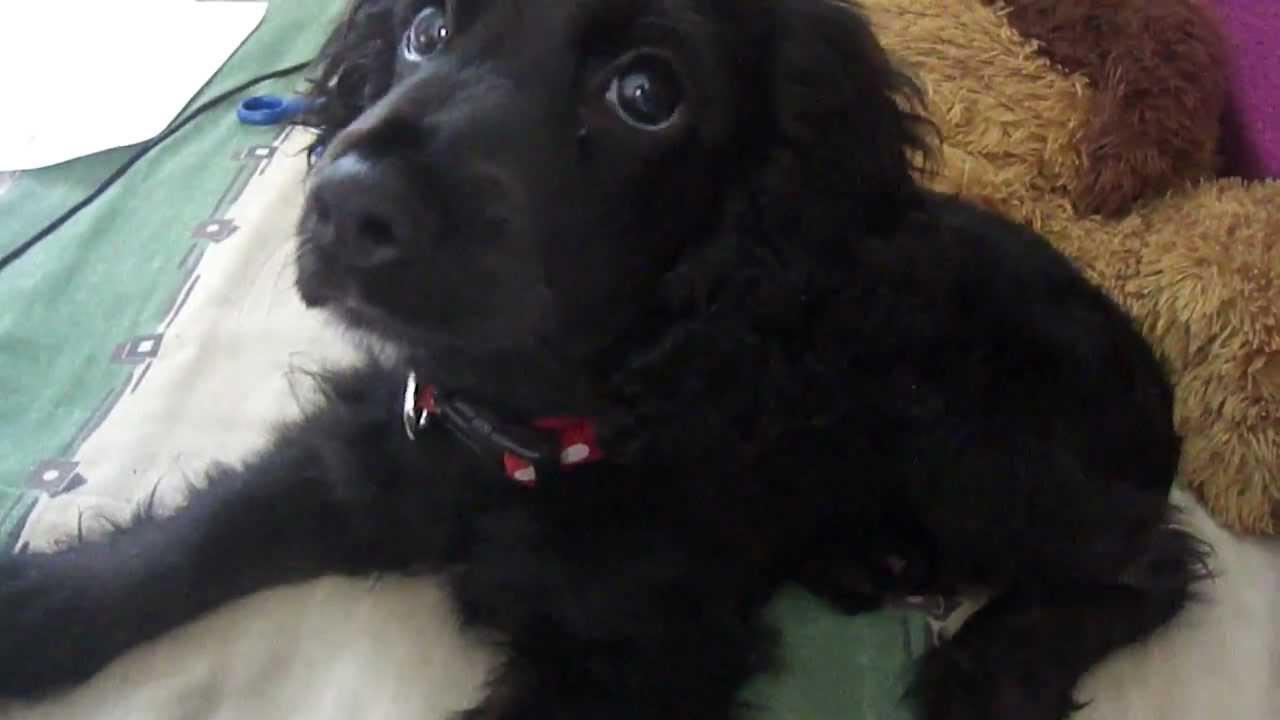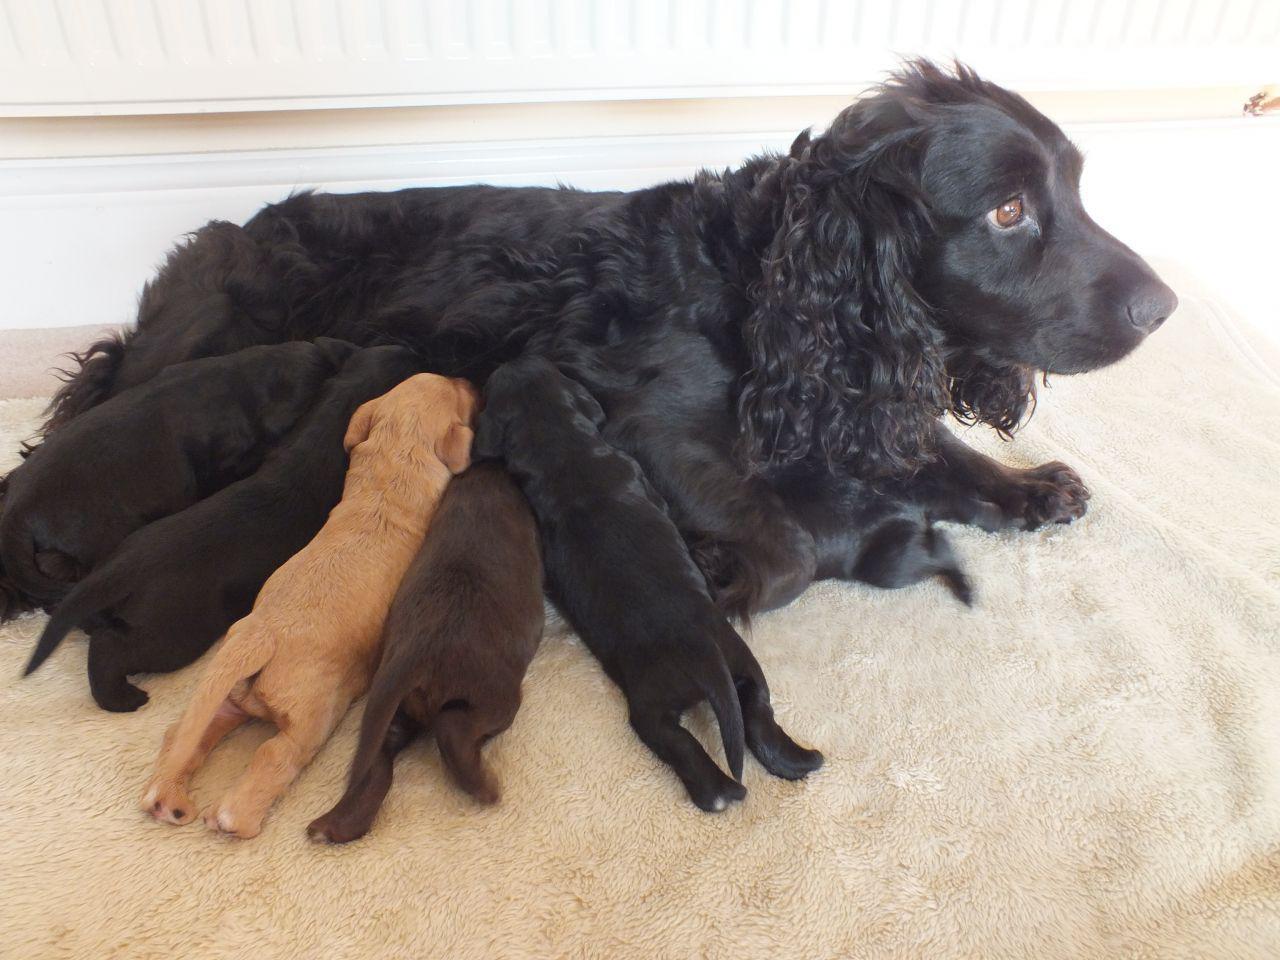The first image is the image on the left, the second image is the image on the right. Examine the images to the left and right. Is the description "There are more black dogs in the right image than in the left." accurate? Answer yes or no. Yes. The first image is the image on the left, the second image is the image on the right. Examine the images to the left and right. Is the description "The black dog in the image on the left is outside on a sunny day." accurate? Answer yes or no. No. 